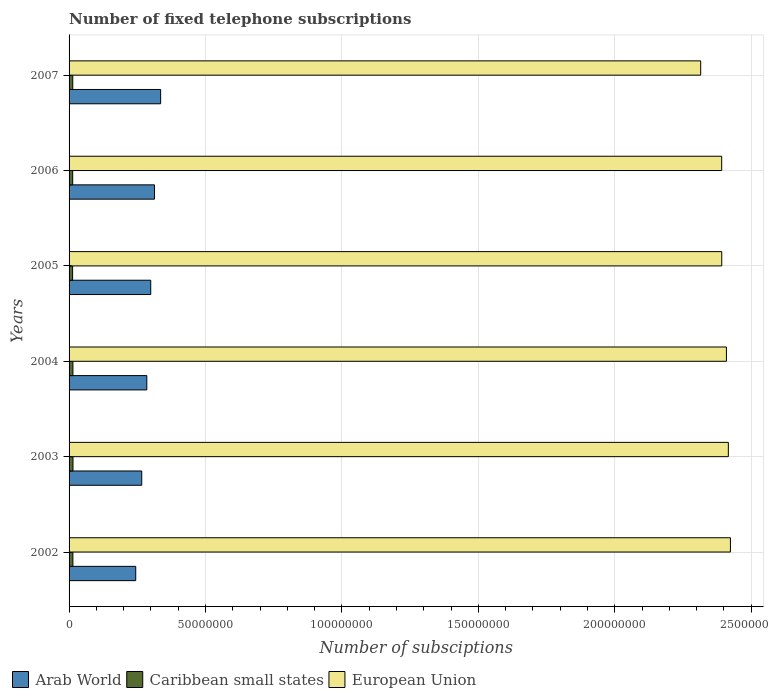What is the number of fixed telephone subscriptions in Arab World in 2007?
Provide a succinct answer. 3.36e+07. Across all years, what is the maximum number of fixed telephone subscriptions in Caribbean small states?
Give a very brief answer. 1.44e+06. Across all years, what is the minimum number of fixed telephone subscriptions in European Union?
Your answer should be compact. 2.31e+08. In which year was the number of fixed telephone subscriptions in Caribbean small states maximum?
Ensure brevity in your answer.  2003. In which year was the number of fixed telephone subscriptions in European Union minimum?
Give a very brief answer. 2007. What is the total number of fixed telephone subscriptions in Caribbean small states in the graph?
Keep it short and to the point. 8.24e+06. What is the difference between the number of fixed telephone subscriptions in Arab World in 2005 and that in 2007?
Give a very brief answer. -3.63e+06. What is the difference between the number of fixed telephone subscriptions in Arab World in 2004 and the number of fixed telephone subscriptions in Caribbean small states in 2005?
Your answer should be very brief. 2.72e+07. What is the average number of fixed telephone subscriptions in Arab World per year?
Your response must be concise. 2.91e+07. In the year 2002, what is the difference between the number of fixed telephone subscriptions in Caribbean small states and number of fixed telephone subscriptions in European Union?
Offer a terse response. -2.41e+08. What is the ratio of the number of fixed telephone subscriptions in Caribbean small states in 2004 to that in 2005?
Your answer should be very brief. 1.09. Is the difference between the number of fixed telephone subscriptions in Caribbean small states in 2003 and 2007 greater than the difference between the number of fixed telephone subscriptions in European Union in 2003 and 2007?
Offer a terse response. No. What is the difference between the highest and the second highest number of fixed telephone subscriptions in Caribbean small states?
Your answer should be very brief. 2.35e+04. What is the difference between the highest and the lowest number of fixed telephone subscriptions in Caribbean small states?
Your answer should be compact. 1.37e+05. In how many years, is the number of fixed telephone subscriptions in Caribbean small states greater than the average number of fixed telephone subscriptions in Caribbean small states taken over all years?
Your response must be concise. 3. What does the 1st bar from the top in 2005 represents?
Make the answer very short. European Union. What does the 1st bar from the bottom in 2002 represents?
Offer a very short reply. Arab World. Are all the bars in the graph horizontal?
Provide a succinct answer. Yes. What is the difference between two consecutive major ticks on the X-axis?
Keep it short and to the point. 5.00e+07. Are the values on the major ticks of X-axis written in scientific E-notation?
Your answer should be compact. No. Does the graph contain any zero values?
Provide a succinct answer. No. Does the graph contain grids?
Provide a succinct answer. Yes. Where does the legend appear in the graph?
Give a very brief answer. Bottom left. How are the legend labels stacked?
Offer a very short reply. Horizontal. What is the title of the graph?
Provide a succinct answer. Number of fixed telephone subscriptions. Does "Moldova" appear as one of the legend labels in the graph?
Your response must be concise. No. What is the label or title of the X-axis?
Ensure brevity in your answer.  Number of subsciptions. What is the label or title of the Y-axis?
Provide a short and direct response. Years. What is the Number of subsciptions in Arab World in 2002?
Provide a succinct answer. 2.44e+07. What is the Number of subsciptions in Caribbean small states in 2002?
Provide a succinct answer. 1.40e+06. What is the Number of subsciptions of European Union in 2002?
Your response must be concise. 2.42e+08. What is the Number of subsciptions in Arab World in 2003?
Your response must be concise. 2.66e+07. What is the Number of subsciptions of Caribbean small states in 2003?
Keep it short and to the point. 1.44e+06. What is the Number of subsciptions of European Union in 2003?
Keep it short and to the point. 2.42e+08. What is the Number of subsciptions of Arab World in 2004?
Provide a succinct answer. 2.85e+07. What is the Number of subsciptions in Caribbean small states in 2004?
Your response must be concise. 1.41e+06. What is the Number of subsciptions of European Union in 2004?
Keep it short and to the point. 2.41e+08. What is the Number of subsciptions of Arab World in 2005?
Offer a very short reply. 2.99e+07. What is the Number of subsciptions of Caribbean small states in 2005?
Your answer should be very brief. 1.30e+06. What is the Number of subsciptions of European Union in 2005?
Provide a short and direct response. 2.39e+08. What is the Number of subsciptions in Arab World in 2006?
Your response must be concise. 3.13e+07. What is the Number of subsciptions of Caribbean small states in 2006?
Offer a very short reply. 1.33e+06. What is the Number of subsciptions in European Union in 2006?
Provide a succinct answer. 2.39e+08. What is the Number of subsciptions of Arab World in 2007?
Provide a succinct answer. 3.36e+07. What is the Number of subsciptions in Caribbean small states in 2007?
Your answer should be compact. 1.36e+06. What is the Number of subsciptions in European Union in 2007?
Make the answer very short. 2.31e+08. Across all years, what is the maximum Number of subsciptions in Arab World?
Offer a terse response. 3.36e+07. Across all years, what is the maximum Number of subsciptions in Caribbean small states?
Keep it short and to the point. 1.44e+06. Across all years, what is the maximum Number of subsciptions of European Union?
Your answer should be very brief. 2.42e+08. Across all years, what is the minimum Number of subsciptions in Arab World?
Give a very brief answer. 2.44e+07. Across all years, what is the minimum Number of subsciptions of Caribbean small states?
Your response must be concise. 1.30e+06. Across all years, what is the minimum Number of subsciptions of European Union?
Make the answer very short. 2.31e+08. What is the total Number of subsciptions in Arab World in the graph?
Offer a terse response. 1.74e+08. What is the total Number of subsciptions in Caribbean small states in the graph?
Offer a very short reply. 8.24e+06. What is the total Number of subsciptions of European Union in the graph?
Provide a succinct answer. 1.43e+09. What is the difference between the Number of subsciptions in Arab World in 2002 and that in 2003?
Offer a terse response. -2.20e+06. What is the difference between the Number of subsciptions of Caribbean small states in 2002 and that in 2003?
Your answer should be very brief. -3.55e+04. What is the difference between the Number of subsciptions of European Union in 2002 and that in 2003?
Provide a short and direct response. 7.60e+05. What is the difference between the Number of subsciptions in Arab World in 2002 and that in 2004?
Your response must be concise. -4.06e+06. What is the difference between the Number of subsciptions of Caribbean small states in 2002 and that in 2004?
Your answer should be very brief. -1.20e+04. What is the difference between the Number of subsciptions in European Union in 2002 and that in 2004?
Provide a succinct answer. 1.46e+06. What is the difference between the Number of subsciptions in Arab World in 2002 and that in 2005?
Make the answer very short. -5.49e+06. What is the difference between the Number of subsciptions in Caribbean small states in 2002 and that in 2005?
Your answer should be very brief. 1.01e+05. What is the difference between the Number of subsciptions in European Union in 2002 and that in 2005?
Offer a very short reply. 3.18e+06. What is the difference between the Number of subsciptions in Arab World in 2002 and that in 2006?
Make the answer very short. -6.87e+06. What is the difference between the Number of subsciptions in Caribbean small states in 2002 and that in 2006?
Provide a succinct answer. 6.70e+04. What is the difference between the Number of subsciptions in European Union in 2002 and that in 2006?
Keep it short and to the point. 3.20e+06. What is the difference between the Number of subsciptions of Arab World in 2002 and that in 2007?
Your answer should be very brief. -9.13e+06. What is the difference between the Number of subsciptions in Caribbean small states in 2002 and that in 2007?
Give a very brief answer. 4.49e+04. What is the difference between the Number of subsciptions in European Union in 2002 and that in 2007?
Give a very brief answer. 1.09e+07. What is the difference between the Number of subsciptions of Arab World in 2003 and that in 2004?
Your answer should be very brief. -1.86e+06. What is the difference between the Number of subsciptions of Caribbean small states in 2003 and that in 2004?
Offer a very short reply. 2.35e+04. What is the difference between the Number of subsciptions in European Union in 2003 and that in 2004?
Your response must be concise. 7.04e+05. What is the difference between the Number of subsciptions in Arab World in 2003 and that in 2005?
Keep it short and to the point. -3.29e+06. What is the difference between the Number of subsciptions in Caribbean small states in 2003 and that in 2005?
Provide a short and direct response. 1.37e+05. What is the difference between the Number of subsciptions in European Union in 2003 and that in 2005?
Provide a short and direct response. 2.42e+06. What is the difference between the Number of subsciptions in Arab World in 2003 and that in 2006?
Your answer should be very brief. -4.67e+06. What is the difference between the Number of subsciptions in Caribbean small states in 2003 and that in 2006?
Give a very brief answer. 1.02e+05. What is the difference between the Number of subsciptions in European Union in 2003 and that in 2006?
Keep it short and to the point. 2.44e+06. What is the difference between the Number of subsciptions of Arab World in 2003 and that in 2007?
Your answer should be compact. -6.93e+06. What is the difference between the Number of subsciptions in Caribbean small states in 2003 and that in 2007?
Keep it short and to the point. 8.03e+04. What is the difference between the Number of subsciptions in European Union in 2003 and that in 2007?
Provide a succinct answer. 1.01e+07. What is the difference between the Number of subsciptions of Arab World in 2004 and that in 2005?
Keep it short and to the point. -1.44e+06. What is the difference between the Number of subsciptions in Caribbean small states in 2004 and that in 2005?
Keep it short and to the point. 1.13e+05. What is the difference between the Number of subsciptions in European Union in 2004 and that in 2005?
Your answer should be very brief. 1.72e+06. What is the difference between the Number of subsciptions of Arab World in 2004 and that in 2006?
Offer a terse response. -2.81e+06. What is the difference between the Number of subsciptions in Caribbean small states in 2004 and that in 2006?
Your response must be concise. 7.90e+04. What is the difference between the Number of subsciptions of European Union in 2004 and that in 2006?
Your answer should be very brief. 1.74e+06. What is the difference between the Number of subsciptions of Arab World in 2004 and that in 2007?
Offer a terse response. -5.07e+06. What is the difference between the Number of subsciptions in Caribbean small states in 2004 and that in 2007?
Provide a succinct answer. 5.68e+04. What is the difference between the Number of subsciptions of European Union in 2004 and that in 2007?
Keep it short and to the point. 9.43e+06. What is the difference between the Number of subsciptions in Arab World in 2005 and that in 2006?
Offer a terse response. -1.38e+06. What is the difference between the Number of subsciptions of Caribbean small states in 2005 and that in 2006?
Keep it short and to the point. -3.43e+04. What is the difference between the Number of subsciptions in European Union in 2005 and that in 2006?
Keep it short and to the point. 2.12e+04. What is the difference between the Number of subsciptions in Arab World in 2005 and that in 2007?
Your response must be concise. -3.63e+06. What is the difference between the Number of subsciptions of Caribbean small states in 2005 and that in 2007?
Provide a short and direct response. -5.64e+04. What is the difference between the Number of subsciptions in European Union in 2005 and that in 2007?
Provide a succinct answer. 7.72e+06. What is the difference between the Number of subsciptions in Arab World in 2006 and that in 2007?
Make the answer very short. -2.26e+06. What is the difference between the Number of subsciptions in Caribbean small states in 2006 and that in 2007?
Keep it short and to the point. -2.21e+04. What is the difference between the Number of subsciptions in European Union in 2006 and that in 2007?
Offer a terse response. 7.69e+06. What is the difference between the Number of subsciptions in Arab World in 2002 and the Number of subsciptions in Caribbean small states in 2003?
Give a very brief answer. 2.30e+07. What is the difference between the Number of subsciptions in Arab World in 2002 and the Number of subsciptions in European Union in 2003?
Give a very brief answer. -2.17e+08. What is the difference between the Number of subsciptions of Caribbean small states in 2002 and the Number of subsciptions of European Union in 2003?
Ensure brevity in your answer.  -2.40e+08. What is the difference between the Number of subsciptions of Arab World in 2002 and the Number of subsciptions of Caribbean small states in 2004?
Your answer should be compact. 2.30e+07. What is the difference between the Number of subsciptions in Arab World in 2002 and the Number of subsciptions in European Union in 2004?
Your answer should be compact. -2.16e+08. What is the difference between the Number of subsciptions of Caribbean small states in 2002 and the Number of subsciptions of European Union in 2004?
Ensure brevity in your answer.  -2.40e+08. What is the difference between the Number of subsciptions in Arab World in 2002 and the Number of subsciptions in Caribbean small states in 2005?
Ensure brevity in your answer.  2.31e+07. What is the difference between the Number of subsciptions of Arab World in 2002 and the Number of subsciptions of European Union in 2005?
Provide a succinct answer. -2.15e+08. What is the difference between the Number of subsciptions in Caribbean small states in 2002 and the Number of subsciptions in European Union in 2005?
Provide a succinct answer. -2.38e+08. What is the difference between the Number of subsciptions in Arab World in 2002 and the Number of subsciptions in Caribbean small states in 2006?
Ensure brevity in your answer.  2.31e+07. What is the difference between the Number of subsciptions of Arab World in 2002 and the Number of subsciptions of European Union in 2006?
Your answer should be compact. -2.15e+08. What is the difference between the Number of subsciptions of Caribbean small states in 2002 and the Number of subsciptions of European Union in 2006?
Your answer should be very brief. -2.38e+08. What is the difference between the Number of subsciptions of Arab World in 2002 and the Number of subsciptions of Caribbean small states in 2007?
Give a very brief answer. 2.31e+07. What is the difference between the Number of subsciptions of Arab World in 2002 and the Number of subsciptions of European Union in 2007?
Give a very brief answer. -2.07e+08. What is the difference between the Number of subsciptions of Caribbean small states in 2002 and the Number of subsciptions of European Union in 2007?
Keep it short and to the point. -2.30e+08. What is the difference between the Number of subsciptions in Arab World in 2003 and the Number of subsciptions in Caribbean small states in 2004?
Offer a very short reply. 2.52e+07. What is the difference between the Number of subsciptions of Arab World in 2003 and the Number of subsciptions of European Union in 2004?
Provide a succinct answer. -2.14e+08. What is the difference between the Number of subsciptions of Caribbean small states in 2003 and the Number of subsciptions of European Union in 2004?
Ensure brevity in your answer.  -2.39e+08. What is the difference between the Number of subsciptions in Arab World in 2003 and the Number of subsciptions in Caribbean small states in 2005?
Your answer should be compact. 2.53e+07. What is the difference between the Number of subsciptions in Arab World in 2003 and the Number of subsciptions in European Union in 2005?
Your answer should be very brief. -2.13e+08. What is the difference between the Number of subsciptions of Caribbean small states in 2003 and the Number of subsciptions of European Union in 2005?
Your answer should be very brief. -2.38e+08. What is the difference between the Number of subsciptions in Arab World in 2003 and the Number of subsciptions in Caribbean small states in 2006?
Offer a very short reply. 2.53e+07. What is the difference between the Number of subsciptions of Arab World in 2003 and the Number of subsciptions of European Union in 2006?
Provide a succinct answer. -2.13e+08. What is the difference between the Number of subsciptions of Caribbean small states in 2003 and the Number of subsciptions of European Union in 2006?
Ensure brevity in your answer.  -2.38e+08. What is the difference between the Number of subsciptions of Arab World in 2003 and the Number of subsciptions of Caribbean small states in 2007?
Make the answer very short. 2.53e+07. What is the difference between the Number of subsciptions in Arab World in 2003 and the Number of subsciptions in European Union in 2007?
Keep it short and to the point. -2.05e+08. What is the difference between the Number of subsciptions in Caribbean small states in 2003 and the Number of subsciptions in European Union in 2007?
Provide a short and direct response. -2.30e+08. What is the difference between the Number of subsciptions in Arab World in 2004 and the Number of subsciptions in Caribbean small states in 2005?
Ensure brevity in your answer.  2.72e+07. What is the difference between the Number of subsciptions in Arab World in 2004 and the Number of subsciptions in European Union in 2005?
Offer a very short reply. -2.11e+08. What is the difference between the Number of subsciptions in Caribbean small states in 2004 and the Number of subsciptions in European Union in 2005?
Offer a very short reply. -2.38e+08. What is the difference between the Number of subsciptions of Arab World in 2004 and the Number of subsciptions of Caribbean small states in 2006?
Offer a very short reply. 2.72e+07. What is the difference between the Number of subsciptions of Arab World in 2004 and the Number of subsciptions of European Union in 2006?
Make the answer very short. -2.11e+08. What is the difference between the Number of subsciptions of Caribbean small states in 2004 and the Number of subsciptions of European Union in 2006?
Provide a succinct answer. -2.38e+08. What is the difference between the Number of subsciptions in Arab World in 2004 and the Number of subsciptions in Caribbean small states in 2007?
Your answer should be compact. 2.71e+07. What is the difference between the Number of subsciptions in Arab World in 2004 and the Number of subsciptions in European Union in 2007?
Ensure brevity in your answer.  -2.03e+08. What is the difference between the Number of subsciptions in Caribbean small states in 2004 and the Number of subsciptions in European Union in 2007?
Your answer should be compact. -2.30e+08. What is the difference between the Number of subsciptions in Arab World in 2005 and the Number of subsciptions in Caribbean small states in 2006?
Your response must be concise. 2.86e+07. What is the difference between the Number of subsciptions in Arab World in 2005 and the Number of subsciptions in European Union in 2006?
Make the answer very short. -2.09e+08. What is the difference between the Number of subsciptions of Caribbean small states in 2005 and the Number of subsciptions of European Union in 2006?
Ensure brevity in your answer.  -2.38e+08. What is the difference between the Number of subsciptions in Arab World in 2005 and the Number of subsciptions in Caribbean small states in 2007?
Ensure brevity in your answer.  2.86e+07. What is the difference between the Number of subsciptions of Arab World in 2005 and the Number of subsciptions of European Union in 2007?
Your response must be concise. -2.02e+08. What is the difference between the Number of subsciptions in Caribbean small states in 2005 and the Number of subsciptions in European Union in 2007?
Keep it short and to the point. -2.30e+08. What is the difference between the Number of subsciptions of Arab World in 2006 and the Number of subsciptions of Caribbean small states in 2007?
Make the answer very short. 2.99e+07. What is the difference between the Number of subsciptions of Arab World in 2006 and the Number of subsciptions of European Union in 2007?
Give a very brief answer. -2.00e+08. What is the difference between the Number of subsciptions in Caribbean small states in 2006 and the Number of subsciptions in European Union in 2007?
Provide a short and direct response. -2.30e+08. What is the average Number of subsciptions of Arab World per year?
Provide a short and direct response. 2.91e+07. What is the average Number of subsciptions in Caribbean small states per year?
Offer a terse response. 1.37e+06. What is the average Number of subsciptions of European Union per year?
Your answer should be very brief. 2.39e+08. In the year 2002, what is the difference between the Number of subsciptions in Arab World and Number of subsciptions in Caribbean small states?
Provide a succinct answer. 2.30e+07. In the year 2002, what is the difference between the Number of subsciptions of Arab World and Number of subsciptions of European Union?
Offer a very short reply. -2.18e+08. In the year 2002, what is the difference between the Number of subsciptions in Caribbean small states and Number of subsciptions in European Union?
Provide a succinct answer. -2.41e+08. In the year 2003, what is the difference between the Number of subsciptions in Arab World and Number of subsciptions in Caribbean small states?
Your answer should be very brief. 2.52e+07. In the year 2003, what is the difference between the Number of subsciptions of Arab World and Number of subsciptions of European Union?
Your answer should be very brief. -2.15e+08. In the year 2003, what is the difference between the Number of subsciptions of Caribbean small states and Number of subsciptions of European Union?
Your answer should be compact. -2.40e+08. In the year 2004, what is the difference between the Number of subsciptions of Arab World and Number of subsciptions of Caribbean small states?
Your response must be concise. 2.71e+07. In the year 2004, what is the difference between the Number of subsciptions of Arab World and Number of subsciptions of European Union?
Keep it short and to the point. -2.12e+08. In the year 2004, what is the difference between the Number of subsciptions in Caribbean small states and Number of subsciptions in European Union?
Give a very brief answer. -2.39e+08. In the year 2005, what is the difference between the Number of subsciptions in Arab World and Number of subsciptions in Caribbean small states?
Offer a very short reply. 2.86e+07. In the year 2005, what is the difference between the Number of subsciptions of Arab World and Number of subsciptions of European Union?
Offer a very short reply. -2.09e+08. In the year 2005, what is the difference between the Number of subsciptions in Caribbean small states and Number of subsciptions in European Union?
Provide a succinct answer. -2.38e+08. In the year 2006, what is the difference between the Number of subsciptions of Arab World and Number of subsciptions of Caribbean small states?
Your response must be concise. 3.00e+07. In the year 2006, what is the difference between the Number of subsciptions in Arab World and Number of subsciptions in European Union?
Keep it short and to the point. -2.08e+08. In the year 2006, what is the difference between the Number of subsciptions in Caribbean small states and Number of subsciptions in European Union?
Your answer should be compact. -2.38e+08. In the year 2007, what is the difference between the Number of subsciptions of Arab World and Number of subsciptions of Caribbean small states?
Ensure brevity in your answer.  3.22e+07. In the year 2007, what is the difference between the Number of subsciptions of Arab World and Number of subsciptions of European Union?
Your response must be concise. -1.98e+08. In the year 2007, what is the difference between the Number of subsciptions of Caribbean small states and Number of subsciptions of European Union?
Your response must be concise. -2.30e+08. What is the ratio of the Number of subsciptions in Arab World in 2002 to that in 2003?
Ensure brevity in your answer.  0.92. What is the ratio of the Number of subsciptions in Caribbean small states in 2002 to that in 2003?
Your response must be concise. 0.98. What is the ratio of the Number of subsciptions in Arab World in 2002 to that in 2004?
Make the answer very short. 0.86. What is the ratio of the Number of subsciptions in Arab World in 2002 to that in 2005?
Offer a very short reply. 0.82. What is the ratio of the Number of subsciptions in Caribbean small states in 2002 to that in 2005?
Make the answer very short. 1.08. What is the ratio of the Number of subsciptions in European Union in 2002 to that in 2005?
Offer a terse response. 1.01. What is the ratio of the Number of subsciptions of Arab World in 2002 to that in 2006?
Give a very brief answer. 0.78. What is the ratio of the Number of subsciptions in Caribbean small states in 2002 to that in 2006?
Make the answer very short. 1.05. What is the ratio of the Number of subsciptions in European Union in 2002 to that in 2006?
Give a very brief answer. 1.01. What is the ratio of the Number of subsciptions of Arab World in 2002 to that in 2007?
Ensure brevity in your answer.  0.73. What is the ratio of the Number of subsciptions of Caribbean small states in 2002 to that in 2007?
Provide a short and direct response. 1.03. What is the ratio of the Number of subsciptions of European Union in 2002 to that in 2007?
Keep it short and to the point. 1.05. What is the ratio of the Number of subsciptions of Arab World in 2003 to that in 2004?
Offer a terse response. 0.93. What is the ratio of the Number of subsciptions of Caribbean small states in 2003 to that in 2004?
Make the answer very short. 1.02. What is the ratio of the Number of subsciptions in Arab World in 2003 to that in 2005?
Your response must be concise. 0.89. What is the ratio of the Number of subsciptions in Caribbean small states in 2003 to that in 2005?
Provide a succinct answer. 1.11. What is the ratio of the Number of subsciptions of European Union in 2003 to that in 2005?
Give a very brief answer. 1.01. What is the ratio of the Number of subsciptions in Arab World in 2003 to that in 2006?
Offer a very short reply. 0.85. What is the ratio of the Number of subsciptions of Caribbean small states in 2003 to that in 2006?
Provide a short and direct response. 1.08. What is the ratio of the Number of subsciptions of European Union in 2003 to that in 2006?
Give a very brief answer. 1.01. What is the ratio of the Number of subsciptions of Arab World in 2003 to that in 2007?
Your answer should be compact. 0.79. What is the ratio of the Number of subsciptions in Caribbean small states in 2003 to that in 2007?
Provide a short and direct response. 1.06. What is the ratio of the Number of subsciptions of European Union in 2003 to that in 2007?
Keep it short and to the point. 1.04. What is the ratio of the Number of subsciptions in Caribbean small states in 2004 to that in 2005?
Provide a short and direct response. 1.09. What is the ratio of the Number of subsciptions of Arab World in 2004 to that in 2006?
Offer a terse response. 0.91. What is the ratio of the Number of subsciptions in Caribbean small states in 2004 to that in 2006?
Provide a succinct answer. 1.06. What is the ratio of the Number of subsciptions in European Union in 2004 to that in 2006?
Your response must be concise. 1.01. What is the ratio of the Number of subsciptions in Arab World in 2004 to that in 2007?
Offer a terse response. 0.85. What is the ratio of the Number of subsciptions of Caribbean small states in 2004 to that in 2007?
Give a very brief answer. 1.04. What is the ratio of the Number of subsciptions in European Union in 2004 to that in 2007?
Offer a terse response. 1.04. What is the ratio of the Number of subsciptions in Arab World in 2005 to that in 2006?
Give a very brief answer. 0.96. What is the ratio of the Number of subsciptions of Caribbean small states in 2005 to that in 2006?
Offer a very short reply. 0.97. What is the ratio of the Number of subsciptions in Arab World in 2005 to that in 2007?
Your answer should be compact. 0.89. What is the ratio of the Number of subsciptions in Caribbean small states in 2005 to that in 2007?
Provide a succinct answer. 0.96. What is the ratio of the Number of subsciptions in European Union in 2005 to that in 2007?
Provide a succinct answer. 1.03. What is the ratio of the Number of subsciptions of Arab World in 2006 to that in 2007?
Provide a short and direct response. 0.93. What is the ratio of the Number of subsciptions of Caribbean small states in 2006 to that in 2007?
Make the answer very short. 0.98. What is the ratio of the Number of subsciptions in European Union in 2006 to that in 2007?
Make the answer very short. 1.03. What is the difference between the highest and the second highest Number of subsciptions of Arab World?
Ensure brevity in your answer.  2.26e+06. What is the difference between the highest and the second highest Number of subsciptions of Caribbean small states?
Provide a succinct answer. 2.35e+04. What is the difference between the highest and the second highest Number of subsciptions in European Union?
Your answer should be very brief. 7.60e+05. What is the difference between the highest and the lowest Number of subsciptions of Arab World?
Offer a very short reply. 9.13e+06. What is the difference between the highest and the lowest Number of subsciptions in Caribbean small states?
Make the answer very short. 1.37e+05. What is the difference between the highest and the lowest Number of subsciptions in European Union?
Your response must be concise. 1.09e+07. 